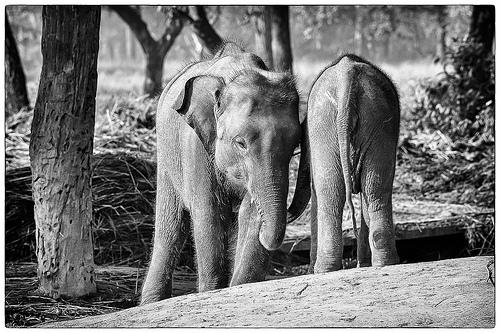Question: what color is the picture?
Choices:
A. Red and blue.
B. Pink and purple.
C. Black and white.
D. Orange and yellow.
Answer with the letter. Answer: C Question: how many elephants are there?
Choices:
A. Three.
B. Four.
C. Five.
D. Two.
Answer with the letter. Answer: D Question: what are the elephants doing?
Choices:
A. Running.
B. Sleeping.
C. Drinking.
D. Standing.
Answer with the letter. Answer: D 